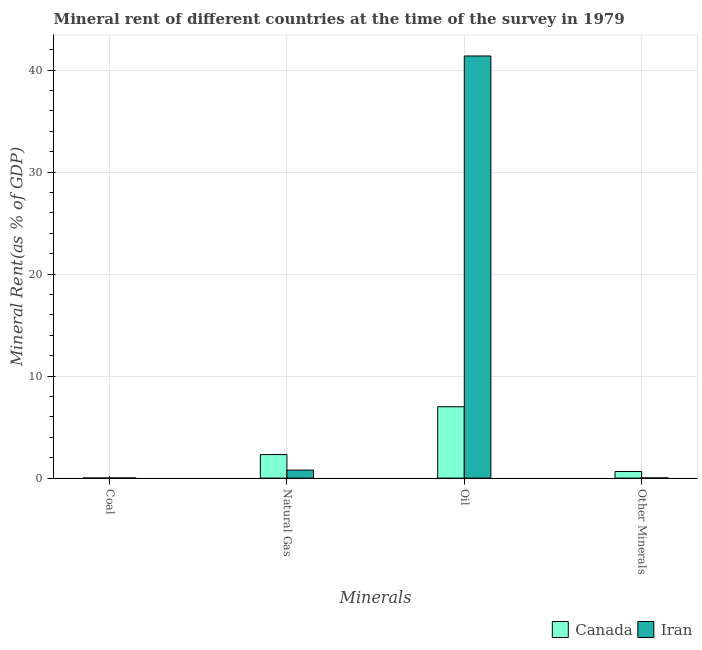How many different coloured bars are there?
Provide a succinct answer. 2. How many groups of bars are there?
Your answer should be very brief. 4. Are the number of bars on each tick of the X-axis equal?
Ensure brevity in your answer.  Yes. How many bars are there on the 1st tick from the left?
Your answer should be compact. 2. What is the label of the 1st group of bars from the left?
Give a very brief answer. Coal. What is the  rent of other minerals in Iran?
Your response must be concise. 0.02. Across all countries, what is the maximum  rent of other minerals?
Your response must be concise. 0.65. Across all countries, what is the minimum  rent of other minerals?
Keep it short and to the point. 0.02. In which country was the oil rent maximum?
Ensure brevity in your answer.  Iran. In which country was the natural gas rent minimum?
Offer a very short reply. Iran. What is the total coal rent in the graph?
Ensure brevity in your answer.  0.02. What is the difference between the coal rent in Canada and that in Iran?
Ensure brevity in your answer.  -0.01. What is the difference between the natural gas rent in Iran and the coal rent in Canada?
Provide a succinct answer. 0.78. What is the average  rent of other minerals per country?
Give a very brief answer. 0.33. What is the difference between the coal rent and  rent of other minerals in Canada?
Offer a terse response. -0.64. In how many countries, is the  rent of other minerals greater than 20 %?
Provide a short and direct response. 0. What is the ratio of the coal rent in Canada to that in Iran?
Give a very brief answer. 0.41. Is the coal rent in Iran less than that in Canada?
Offer a very short reply. No. What is the difference between the highest and the second highest  rent of other minerals?
Offer a very short reply. 0.63. What is the difference between the highest and the lowest  rent of other minerals?
Give a very brief answer. 0.63. Is the sum of the oil rent in Canada and Iran greater than the maximum  rent of other minerals across all countries?
Your answer should be compact. Yes. What does the 2nd bar from the left in Oil represents?
Keep it short and to the point. Iran. What does the 1st bar from the right in Other Minerals represents?
Give a very brief answer. Iran. How many bars are there?
Ensure brevity in your answer.  8. Are all the bars in the graph horizontal?
Keep it short and to the point. No. How many countries are there in the graph?
Provide a short and direct response. 2. What is the difference between two consecutive major ticks on the Y-axis?
Your answer should be very brief. 10. How many legend labels are there?
Give a very brief answer. 2. How are the legend labels stacked?
Your response must be concise. Horizontal. What is the title of the graph?
Keep it short and to the point. Mineral rent of different countries at the time of the survey in 1979. Does "Europe(all income levels)" appear as one of the legend labels in the graph?
Ensure brevity in your answer.  No. What is the label or title of the X-axis?
Your response must be concise. Minerals. What is the label or title of the Y-axis?
Your response must be concise. Mineral Rent(as % of GDP). What is the Mineral Rent(as % of GDP) of Canada in Coal?
Your response must be concise. 0.01. What is the Mineral Rent(as % of GDP) of Iran in Coal?
Provide a short and direct response. 0.01. What is the Mineral Rent(as % of GDP) in Canada in Natural Gas?
Give a very brief answer. 2.31. What is the Mineral Rent(as % of GDP) in Iran in Natural Gas?
Ensure brevity in your answer.  0.79. What is the Mineral Rent(as % of GDP) of Canada in Oil?
Provide a short and direct response. 7. What is the Mineral Rent(as % of GDP) in Iran in Oil?
Offer a very short reply. 41.38. What is the Mineral Rent(as % of GDP) in Canada in Other Minerals?
Ensure brevity in your answer.  0.65. What is the Mineral Rent(as % of GDP) of Iran in Other Minerals?
Your response must be concise. 0.02. Across all Minerals, what is the maximum Mineral Rent(as % of GDP) of Canada?
Provide a short and direct response. 7. Across all Minerals, what is the maximum Mineral Rent(as % of GDP) in Iran?
Make the answer very short. 41.38. Across all Minerals, what is the minimum Mineral Rent(as % of GDP) in Canada?
Give a very brief answer. 0.01. Across all Minerals, what is the minimum Mineral Rent(as % of GDP) in Iran?
Ensure brevity in your answer.  0.01. What is the total Mineral Rent(as % of GDP) of Canada in the graph?
Provide a succinct answer. 9.96. What is the total Mineral Rent(as % of GDP) in Iran in the graph?
Keep it short and to the point. 42.2. What is the difference between the Mineral Rent(as % of GDP) in Canada in Coal and that in Natural Gas?
Offer a very short reply. -2.3. What is the difference between the Mineral Rent(as % of GDP) in Iran in Coal and that in Natural Gas?
Give a very brief answer. -0.77. What is the difference between the Mineral Rent(as % of GDP) of Canada in Coal and that in Oil?
Your response must be concise. -6.99. What is the difference between the Mineral Rent(as % of GDP) in Iran in Coal and that in Oil?
Offer a terse response. -41.37. What is the difference between the Mineral Rent(as % of GDP) in Canada in Coal and that in Other Minerals?
Keep it short and to the point. -0.64. What is the difference between the Mineral Rent(as % of GDP) in Iran in Coal and that in Other Minerals?
Make the answer very short. -0.01. What is the difference between the Mineral Rent(as % of GDP) in Canada in Natural Gas and that in Oil?
Provide a succinct answer. -4.69. What is the difference between the Mineral Rent(as % of GDP) in Iran in Natural Gas and that in Oil?
Offer a terse response. -40.6. What is the difference between the Mineral Rent(as % of GDP) in Canada in Natural Gas and that in Other Minerals?
Provide a short and direct response. 1.66. What is the difference between the Mineral Rent(as % of GDP) of Iran in Natural Gas and that in Other Minerals?
Keep it short and to the point. 0.77. What is the difference between the Mineral Rent(as % of GDP) in Canada in Oil and that in Other Minerals?
Offer a terse response. 6.35. What is the difference between the Mineral Rent(as % of GDP) in Iran in Oil and that in Other Minerals?
Provide a short and direct response. 41.37. What is the difference between the Mineral Rent(as % of GDP) in Canada in Coal and the Mineral Rent(as % of GDP) in Iran in Natural Gas?
Your response must be concise. -0.78. What is the difference between the Mineral Rent(as % of GDP) in Canada in Coal and the Mineral Rent(as % of GDP) in Iran in Oil?
Give a very brief answer. -41.38. What is the difference between the Mineral Rent(as % of GDP) in Canada in Coal and the Mineral Rent(as % of GDP) in Iran in Other Minerals?
Offer a terse response. -0.01. What is the difference between the Mineral Rent(as % of GDP) of Canada in Natural Gas and the Mineral Rent(as % of GDP) of Iran in Oil?
Keep it short and to the point. -39.08. What is the difference between the Mineral Rent(as % of GDP) of Canada in Natural Gas and the Mineral Rent(as % of GDP) of Iran in Other Minerals?
Your answer should be compact. 2.29. What is the difference between the Mineral Rent(as % of GDP) of Canada in Oil and the Mineral Rent(as % of GDP) of Iran in Other Minerals?
Offer a terse response. 6.98. What is the average Mineral Rent(as % of GDP) of Canada per Minerals?
Keep it short and to the point. 2.49. What is the average Mineral Rent(as % of GDP) of Iran per Minerals?
Provide a succinct answer. 10.55. What is the difference between the Mineral Rent(as % of GDP) in Canada and Mineral Rent(as % of GDP) in Iran in Coal?
Offer a terse response. -0.01. What is the difference between the Mineral Rent(as % of GDP) in Canada and Mineral Rent(as % of GDP) in Iran in Natural Gas?
Make the answer very short. 1.52. What is the difference between the Mineral Rent(as % of GDP) in Canada and Mineral Rent(as % of GDP) in Iran in Oil?
Give a very brief answer. -34.39. What is the difference between the Mineral Rent(as % of GDP) of Canada and Mineral Rent(as % of GDP) of Iran in Other Minerals?
Offer a terse response. 0.63. What is the ratio of the Mineral Rent(as % of GDP) of Canada in Coal to that in Natural Gas?
Offer a terse response. 0. What is the ratio of the Mineral Rent(as % of GDP) of Iran in Coal to that in Natural Gas?
Give a very brief answer. 0.02. What is the ratio of the Mineral Rent(as % of GDP) of Canada in Coal to that in Oil?
Make the answer very short. 0. What is the ratio of the Mineral Rent(as % of GDP) in Canada in Coal to that in Other Minerals?
Provide a short and direct response. 0.01. What is the ratio of the Mineral Rent(as % of GDP) in Iran in Coal to that in Other Minerals?
Your answer should be very brief. 0.66. What is the ratio of the Mineral Rent(as % of GDP) in Canada in Natural Gas to that in Oil?
Give a very brief answer. 0.33. What is the ratio of the Mineral Rent(as % of GDP) of Iran in Natural Gas to that in Oil?
Offer a terse response. 0.02. What is the ratio of the Mineral Rent(as % of GDP) of Canada in Natural Gas to that in Other Minerals?
Your answer should be very brief. 3.57. What is the ratio of the Mineral Rent(as % of GDP) in Iran in Natural Gas to that in Other Minerals?
Provide a succinct answer. 41.9. What is the ratio of the Mineral Rent(as % of GDP) of Canada in Oil to that in Other Minerals?
Offer a terse response. 10.81. What is the ratio of the Mineral Rent(as % of GDP) in Iran in Oil to that in Other Minerals?
Offer a very short reply. 2204.33. What is the difference between the highest and the second highest Mineral Rent(as % of GDP) of Canada?
Provide a short and direct response. 4.69. What is the difference between the highest and the second highest Mineral Rent(as % of GDP) of Iran?
Your answer should be compact. 40.6. What is the difference between the highest and the lowest Mineral Rent(as % of GDP) of Canada?
Ensure brevity in your answer.  6.99. What is the difference between the highest and the lowest Mineral Rent(as % of GDP) in Iran?
Offer a very short reply. 41.37. 